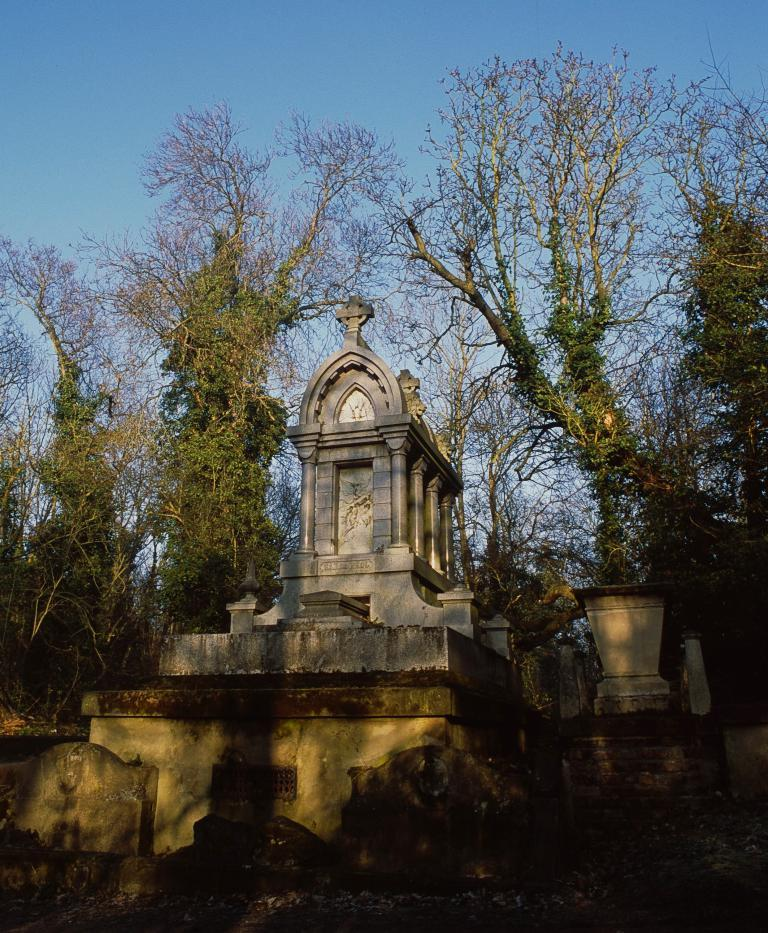What type of structure is visible in the image? There is a mausoleum in the image. Is the mausoleum part of a larger structure? Yes, the mausoleum appears to be part of a building. What type of vegetation can be seen in the image? There are trees in the image. What is visible at the top of the image? The sky is visible at the top of the image. What type of property is for sale in the image? There is no information about property for sale in the image; it primarily features a mausoleum and surrounding trees. What season is depicted in the image? The image does not provide enough information to determine the season; it only shows the mausoleum, trees, and sky. 